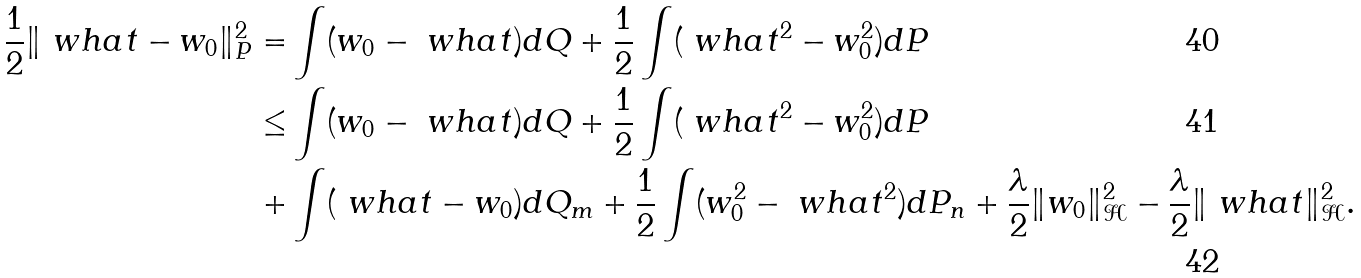Convert formula to latex. <formula><loc_0><loc_0><loc_500><loc_500>\frac { 1 } { 2 } \| \ w h a t - w _ { 0 } \| ^ { 2 } _ { P } = & \int ( w _ { 0 } - \ w h a t ) d Q + \frac { 1 } { 2 } \int ( \ w h a t ^ { 2 } - w _ { 0 } ^ { 2 } ) d P \\ \leq & \int ( w _ { 0 } - \ w h a t ) d Q + \frac { 1 } { 2 } \int ( \ w h a t ^ { 2 } - w _ { 0 } ^ { 2 } ) d P \\ + & \int ( \ w h a t - w _ { 0 } ) d Q _ { m } + \frac { 1 } { 2 } \int ( w _ { 0 } ^ { 2 } - \ w h a t ^ { 2 } ) d P _ { n } + \frac { \lambda } { 2 } \| w _ { 0 } \| _ { \mathcal { H } } ^ { 2 } - \frac { \lambda } { 2 } \| \ w h a t \| _ { \mathcal { H } } ^ { 2 } .</formula> 